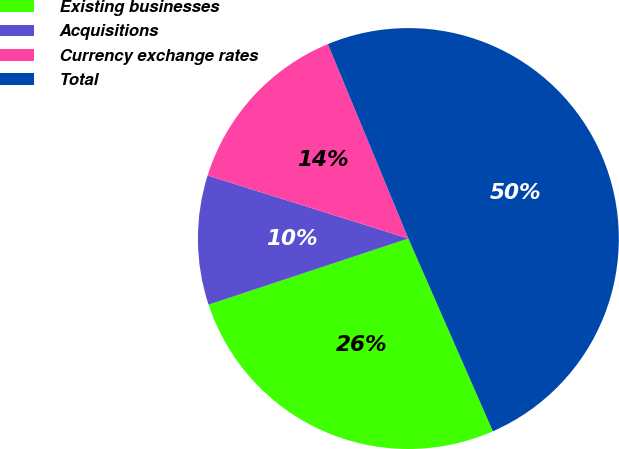Convert chart. <chart><loc_0><loc_0><loc_500><loc_500><pie_chart><fcel>Existing businesses<fcel>Acquisitions<fcel>Currency exchange rates<fcel>Total<nl><fcel>26.49%<fcel>9.93%<fcel>13.91%<fcel>49.67%<nl></chart> 